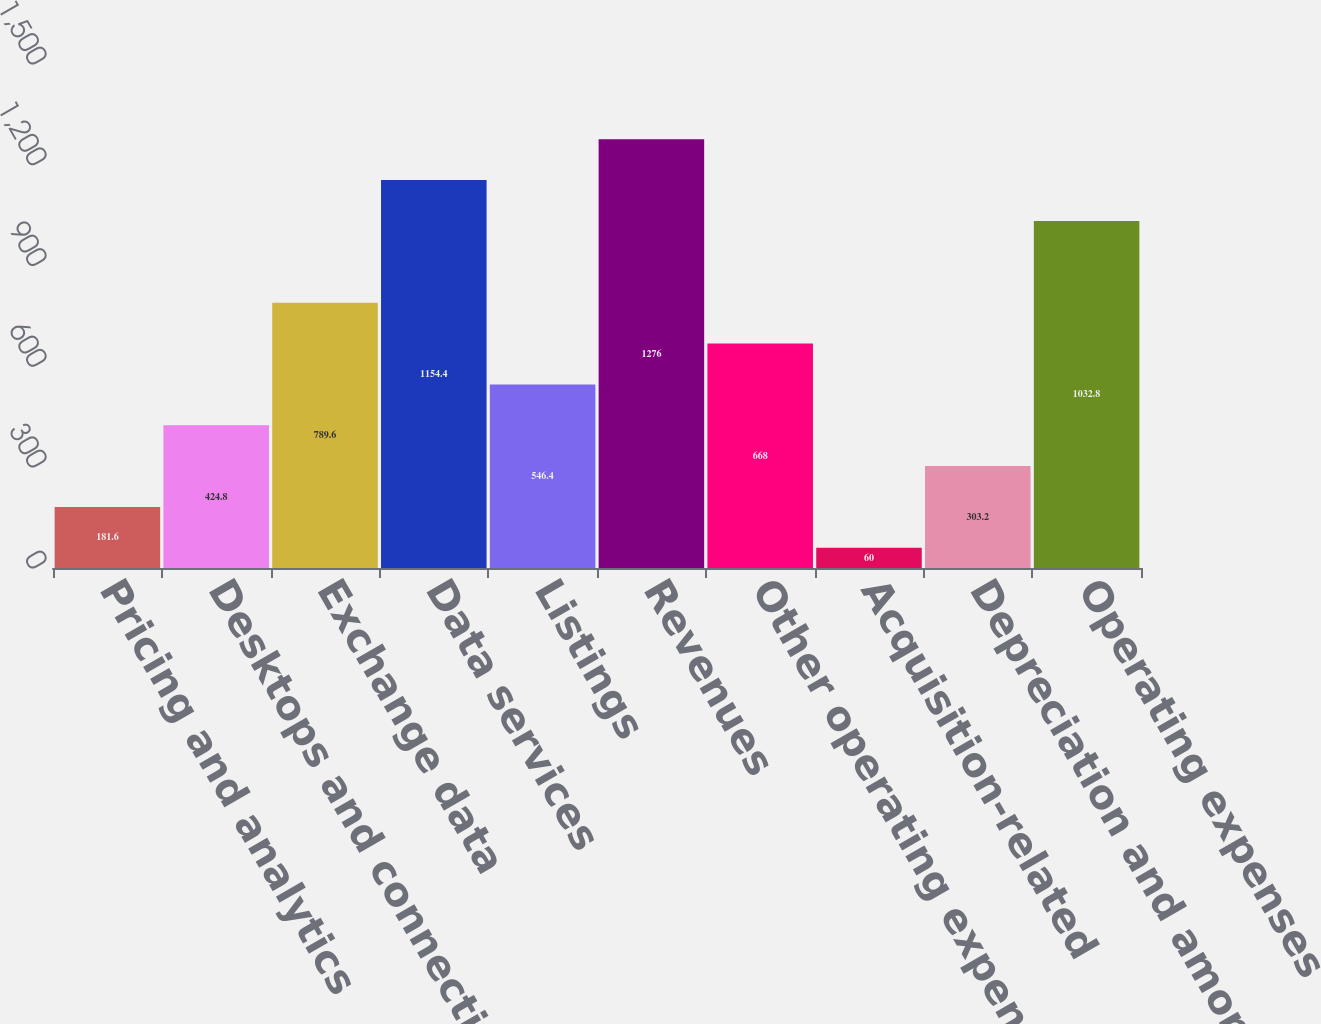<chart> <loc_0><loc_0><loc_500><loc_500><bar_chart><fcel>Pricing and analytics<fcel>Desktops and connectivity<fcel>Exchange data<fcel>Data services<fcel>Listings<fcel>Revenues<fcel>Other operating expenses<fcel>Acquisition-related<fcel>Depreciation and amortization<fcel>Operating expenses<nl><fcel>181.6<fcel>424.8<fcel>789.6<fcel>1154.4<fcel>546.4<fcel>1276<fcel>668<fcel>60<fcel>303.2<fcel>1032.8<nl></chart> 